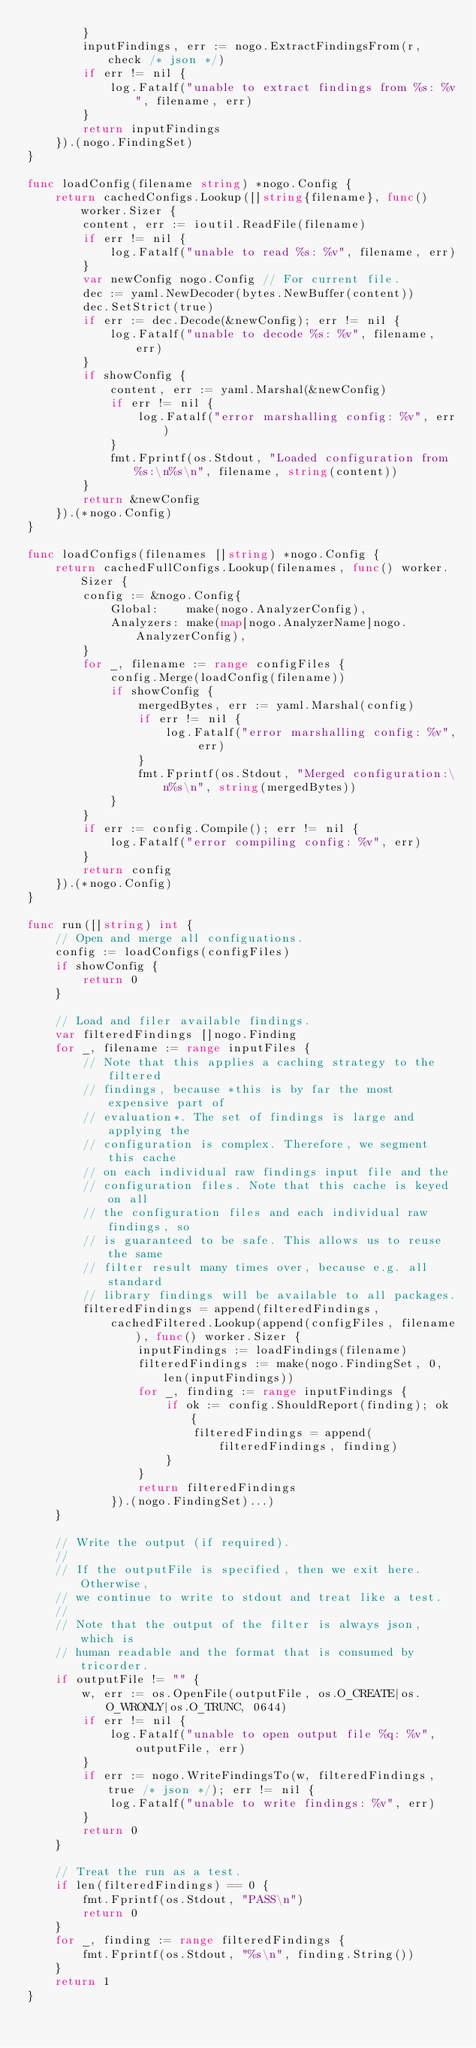Convert code to text. <code><loc_0><loc_0><loc_500><loc_500><_Go_>		}
		inputFindings, err := nogo.ExtractFindingsFrom(r, check /* json */)
		if err != nil {
			log.Fatalf("unable to extract findings from %s: %v", filename, err)
		}
		return inputFindings
	}).(nogo.FindingSet)
}

func loadConfig(filename string) *nogo.Config {
	return cachedConfigs.Lookup([]string{filename}, func() worker.Sizer {
		content, err := ioutil.ReadFile(filename)
		if err != nil {
			log.Fatalf("unable to read %s: %v", filename, err)
		}
		var newConfig nogo.Config // For current file.
		dec := yaml.NewDecoder(bytes.NewBuffer(content))
		dec.SetStrict(true)
		if err := dec.Decode(&newConfig); err != nil {
			log.Fatalf("unable to decode %s: %v", filename, err)
		}
		if showConfig {
			content, err := yaml.Marshal(&newConfig)
			if err != nil {
				log.Fatalf("error marshalling config: %v", err)
			}
			fmt.Fprintf(os.Stdout, "Loaded configuration from %s:\n%s\n", filename, string(content))
		}
		return &newConfig
	}).(*nogo.Config)
}

func loadConfigs(filenames []string) *nogo.Config {
	return cachedFullConfigs.Lookup(filenames, func() worker.Sizer {
		config := &nogo.Config{
			Global:    make(nogo.AnalyzerConfig),
			Analyzers: make(map[nogo.AnalyzerName]nogo.AnalyzerConfig),
		}
		for _, filename := range configFiles {
			config.Merge(loadConfig(filename))
			if showConfig {
				mergedBytes, err := yaml.Marshal(config)
				if err != nil {
					log.Fatalf("error marshalling config: %v", err)
				}
				fmt.Fprintf(os.Stdout, "Merged configuration:\n%s\n", string(mergedBytes))
			}
		}
		if err := config.Compile(); err != nil {
			log.Fatalf("error compiling config: %v", err)
		}
		return config
	}).(*nogo.Config)
}

func run([]string) int {
	// Open and merge all configuations.
	config := loadConfigs(configFiles)
	if showConfig {
		return 0
	}

	// Load and filer available findings.
	var filteredFindings []nogo.Finding
	for _, filename := range inputFiles {
		// Note that this applies a caching strategy to the filtered
		// findings, because *this is by far the most expensive part of
		// evaluation*. The set of findings is large and applying the
		// configuration is complex. Therefore, we segment this cache
		// on each individual raw findings input file and the
		// configuration files. Note that this cache is keyed on all
		// the configuration files and each individual raw findings, so
		// is guaranteed to be safe. This allows us to reuse the same
		// filter result many times over, because e.g. all standard
		// library findings will be available to all packages.
		filteredFindings = append(filteredFindings,
			cachedFiltered.Lookup(append(configFiles, filename), func() worker.Sizer {
				inputFindings := loadFindings(filename)
				filteredFindings := make(nogo.FindingSet, 0, len(inputFindings))
				for _, finding := range inputFindings {
					if ok := config.ShouldReport(finding); ok {
						filteredFindings = append(filteredFindings, finding)
					}
				}
				return filteredFindings
			}).(nogo.FindingSet)...)
	}

	// Write the output (if required).
	//
	// If the outputFile is specified, then we exit here. Otherwise,
	// we continue to write to stdout and treat like a test.
	//
	// Note that the output of the filter is always json, which is
	// human readable and the format that is consumed by tricorder.
	if outputFile != "" {
		w, err := os.OpenFile(outputFile, os.O_CREATE|os.O_WRONLY|os.O_TRUNC, 0644)
		if err != nil {
			log.Fatalf("unable to open output file %q: %v", outputFile, err)
		}
		if err := nogo.WriteFindingsTo(w, filteredFindings, true /* json */); err != nil {
			log.Fatalf("unable to write findings: %v", err)
		}
		return 0
	}

	// Treat the run as a test.
	if len(filteredFindings) == 0 {
		fmt.Fprintf(os.Stdout, "PASS\n")
		return 0
	}
	for _, finding := range filteredFindings {
		fmt.Fprintf(os.Stdout, "%s\n", finding.String())
	}
	return 1
}
</code> 